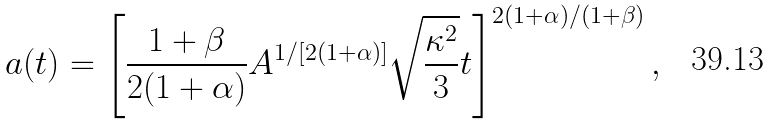<formula> <loc_0><loc_0><loc_500><loc_500>a ( t ) = \left [ \frac { 1 + \beta } { 2 ( 1 + \alpha ) } A ^ { 1 / [ 2 ( 1 + \alpha ) ] } \sqrt { \frac { \kappa ^ { 2 } } { 3 } } t \right ] ^ { 2 ( 1 + \alpha ) / ( 1 + \beta ) } ,</formula> 